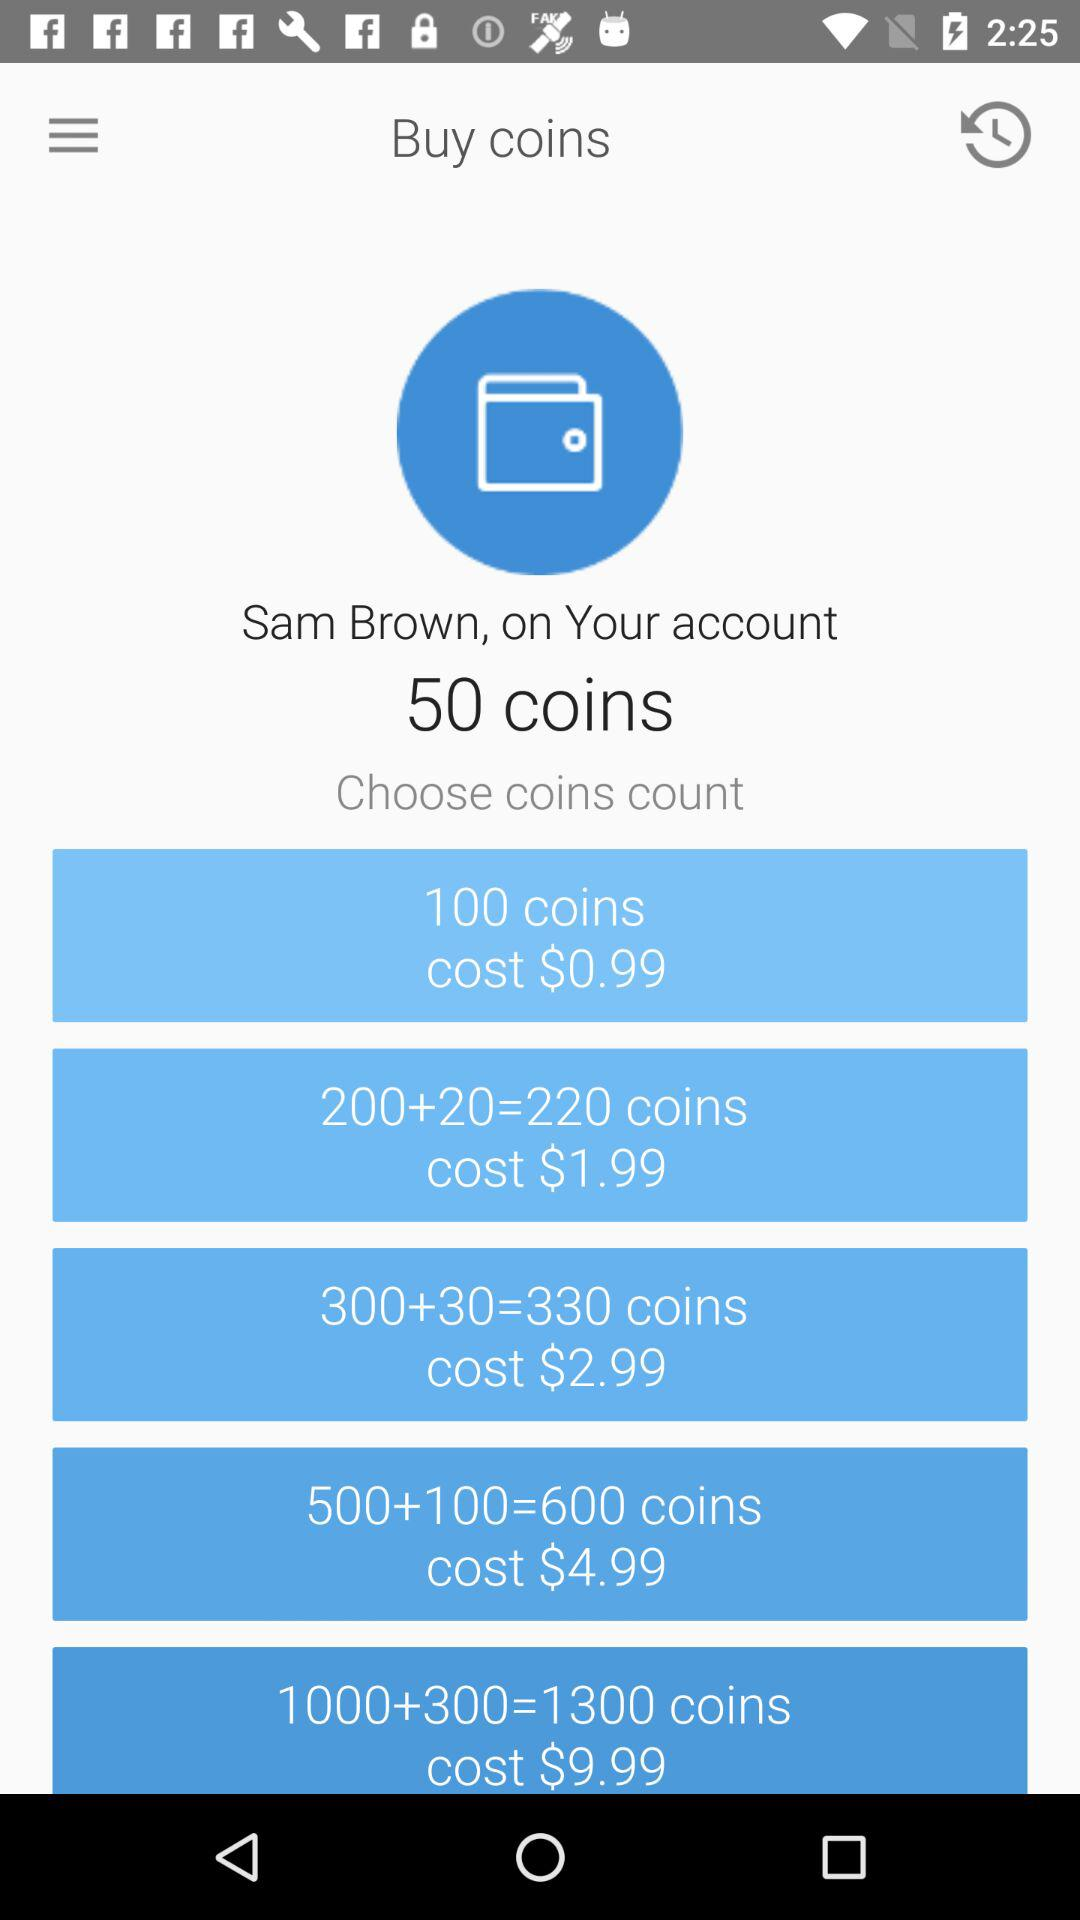How much do 100 coins cost? 100 coins cost $0.99. 